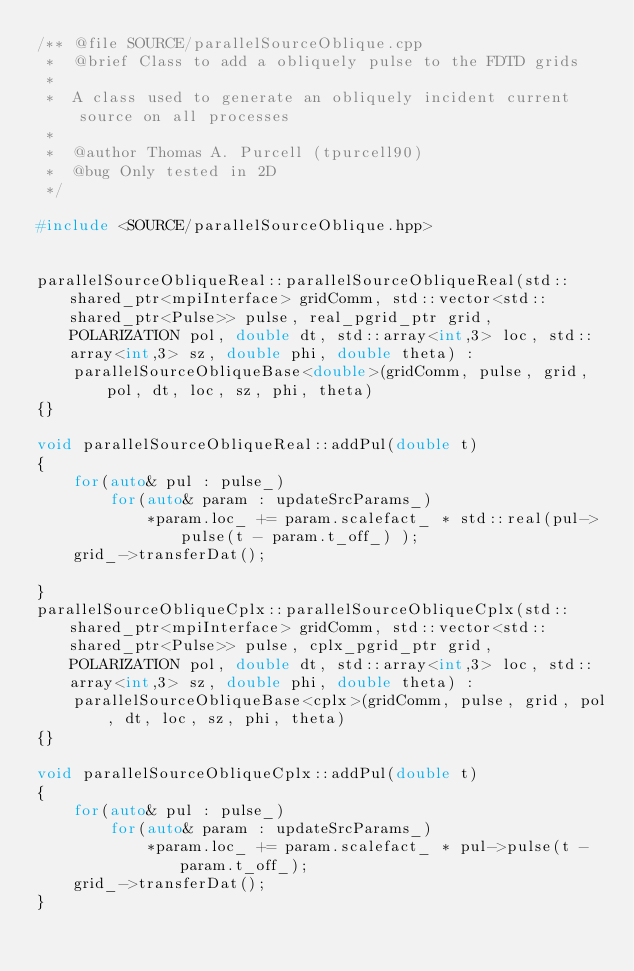<code> <loc_0><loc_0><loc_500><loc_500><_C++_>/** @file SOURCE/parallelSourceOblique.cpp
 *  @brief Class to add a obliquely pulse to the FDTD grids
 *
 *  A class used to generate an obliquely incident current source on all processes
 *
 *  @author Thomas A. Purcell (tpurcell90)
 *  @bug Only tested in 2D
 */

#include <SOURCE/parallelSourceOblique.hpp>


parallelSourceObliqueReal::parallelSourceObliqueReal(std::shared_ptr<mpiInterface> gridComm, std::vector<std::shared_ptr<Pulse>> pulse, real_pgrid_ptr grid, POLARIZATION pol, double dt, std::array<int,3> loc, std::array<int,3> sz, double phi, double theta) :
    parallelSourceObliqueBase<double>(gridComm, pulse, grid, pol, dt, loc, sz, phi, theta)
{}

void parallelSourceObliqueReal::addPul(double t)
{
    for(auto& pul : pulse_)
        for(auto& param : updateSrcParams_)
            *param.loc_ += param.scalefact_ * std::real(pul->pulse(t - param.t_off_) );
    grid_->transferDat();

}
parallelSourceObliqueCplx::parallelSourceObliqueCplx(std::shared_ptr<mpiInterface> gridComm, std::vector<std::shared_ptr<Pulse>> pulse, cplx_pgrid_ptr grid, POLARIZATION pol, double dt, std::array<int,3> loc, std::array<int,3> sz, double phi, double theta) :
    parallelSourceObliqueBase<cplx>(gridComm, pulse, grid, pol, dt, loc, sz, phi, theta)
{}

void parallelSourceObliqueCplx::addPul(double t)
{
    for(auto& pul : pulse_)
        for(auto& param : updateSrcParams_)
            *param.loc_ += param.scalefact_ * pul->pulse(t - param.t_off_);
    grid_->transferDat();
}
</code> 